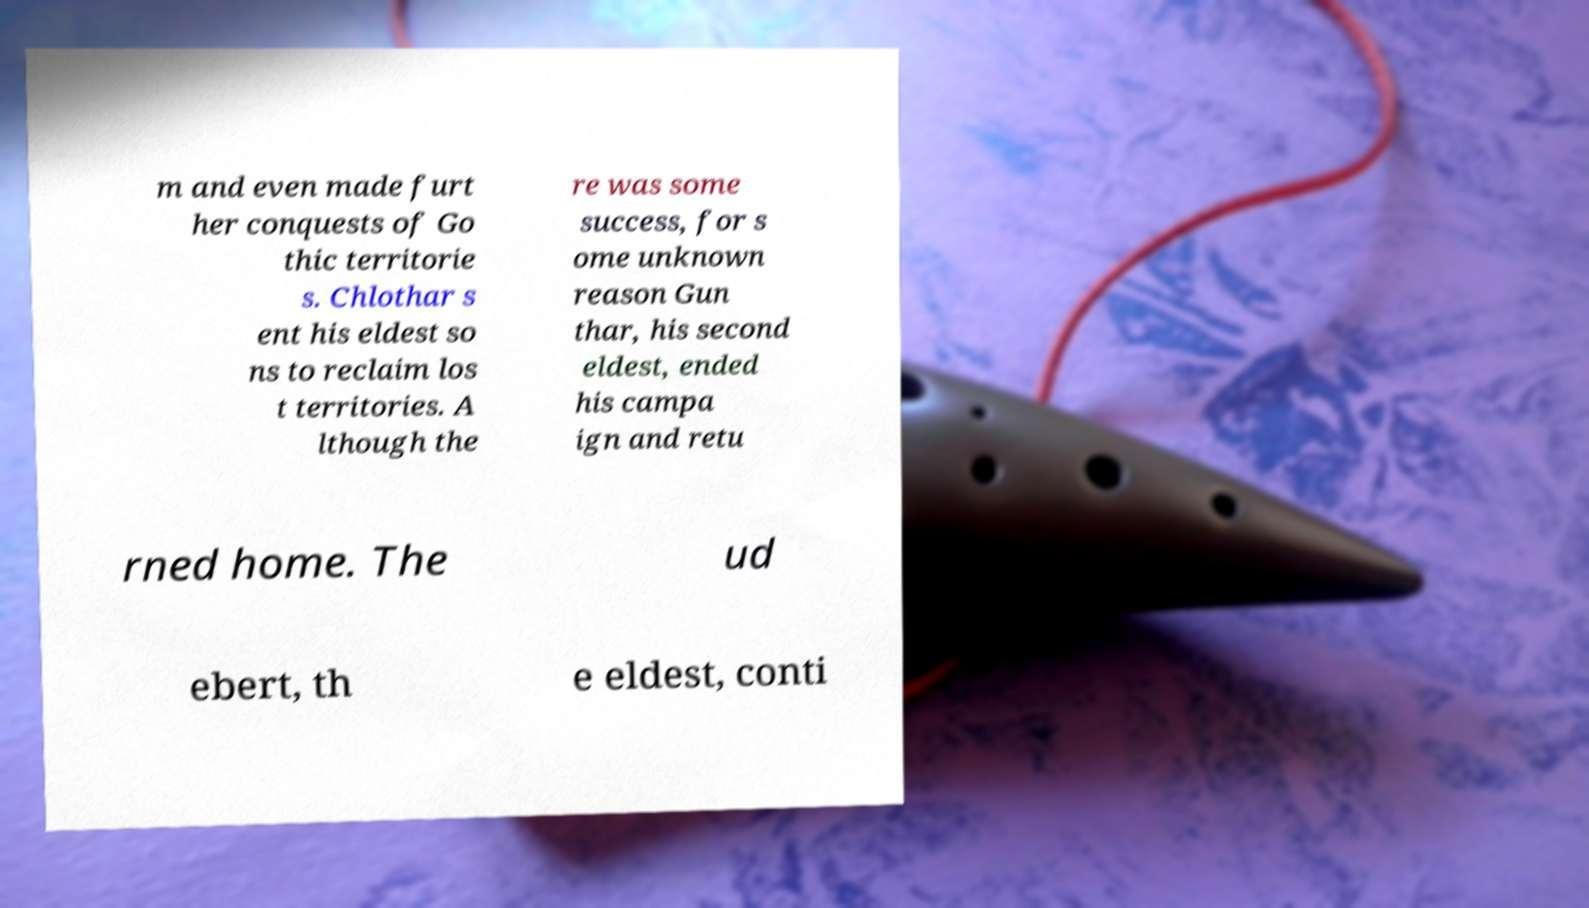Could you extract and type out the text from this image? m and even made furt her conquests of Go thic territorie s. Chlothar s ent his eldest so ns to reclaim los t territories. A lthough the re was some success, for s ome unknown reason Gun thar, his second eldest, ended his campa ign and retu rned home. The ud ebert, th e eldest, conti 